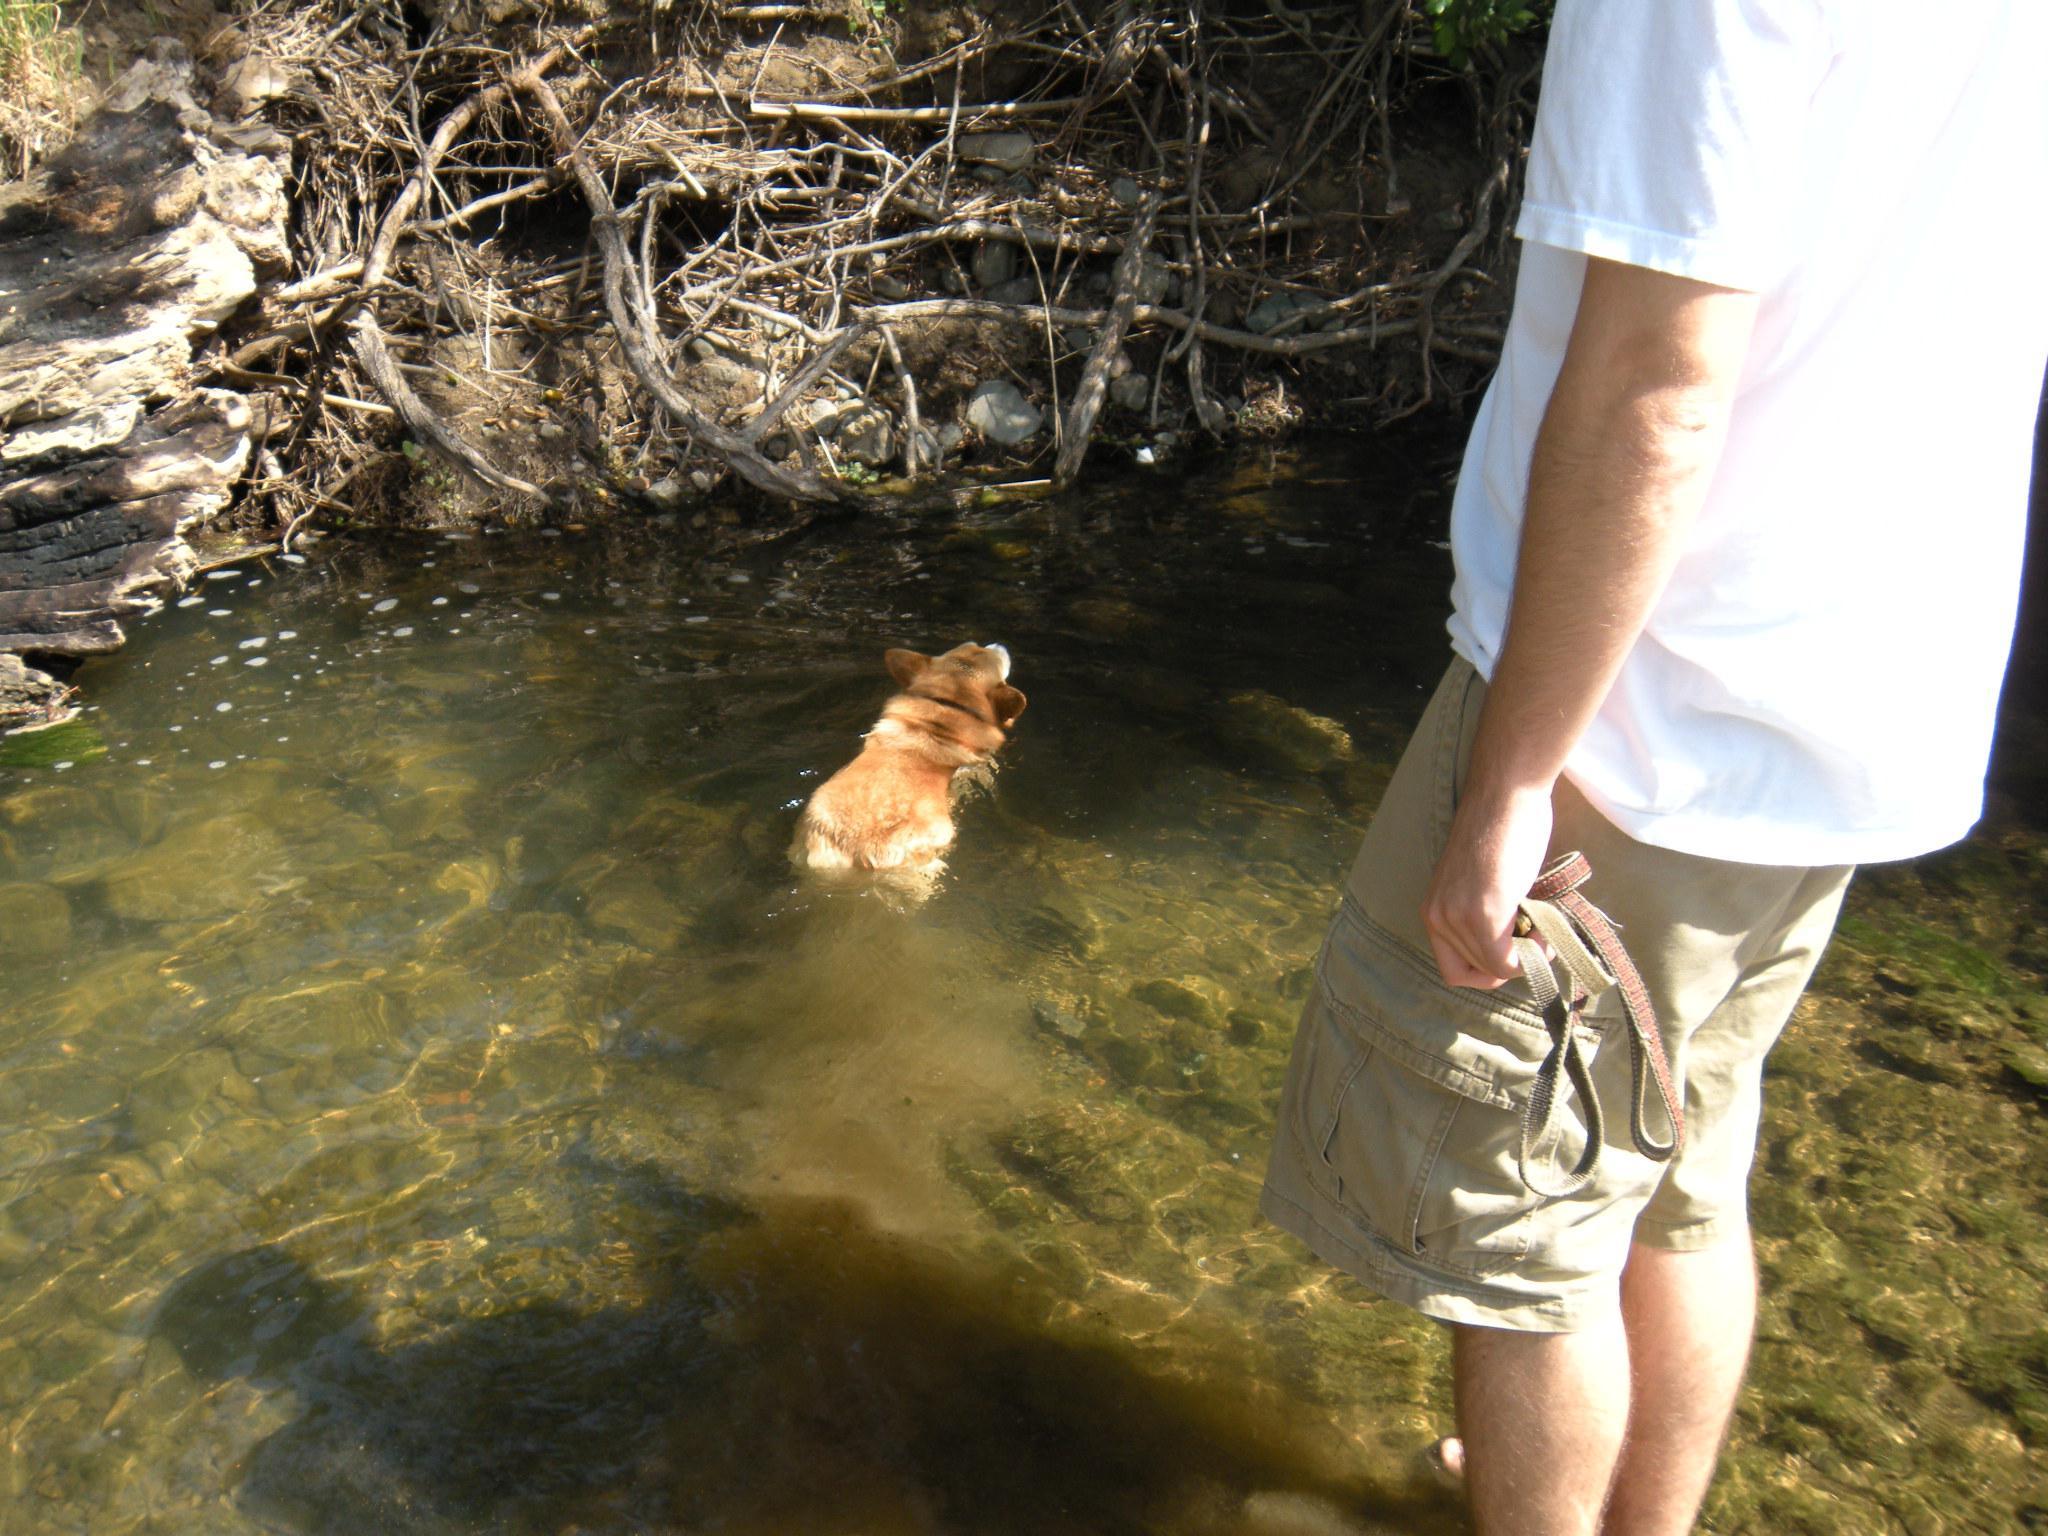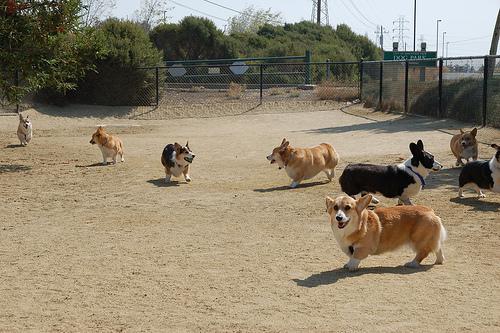The first image is the image on the left, the second image is the image on the right. Assess this claim about the two images: "The left image contains no more than two corgi dogs.". Correct or not? Answer yes or no. Yes. The first image is the image on the left, the second image is the image on the right. Assess this claim about the two images: "One image features a horizontal row of at least four corgis on the grass, and the other image includes at least one corgi on an elevated spot.". Correct or not? Answer yes or no. No. 